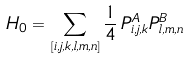<formula> <loc_0><loc_0><loc_500><loc_500>H _ { 0 } = \sum _ { [ i , j , k , l , m , n ] } \frac { 1 } { 4 } \, P _ { i , j , k } ^ { A } P _ { l , m , n } ^ { B }</formula> 